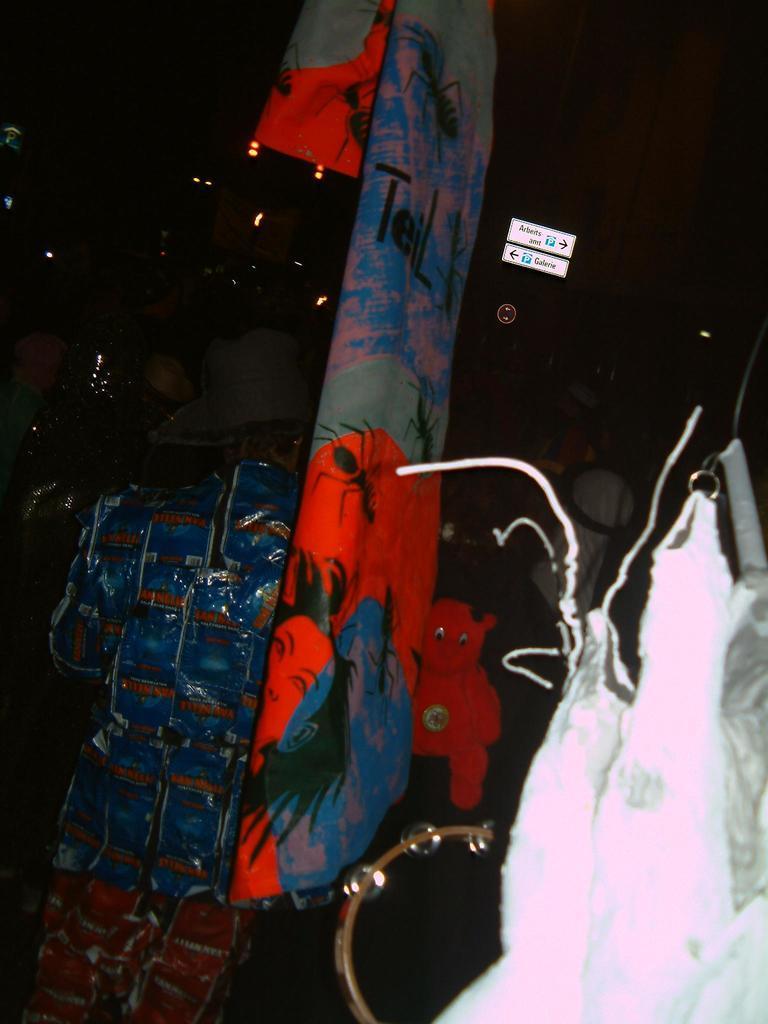How would you summarize this image in a sentence or two? In the picture we can see a handbag and near to it, we can see a piece of cloth which is painted and hanged to the ceiling and in front of it, we can see a man standing and he is with a hat and in the background we can see dark with some part of lights and indicating arrow boards. 